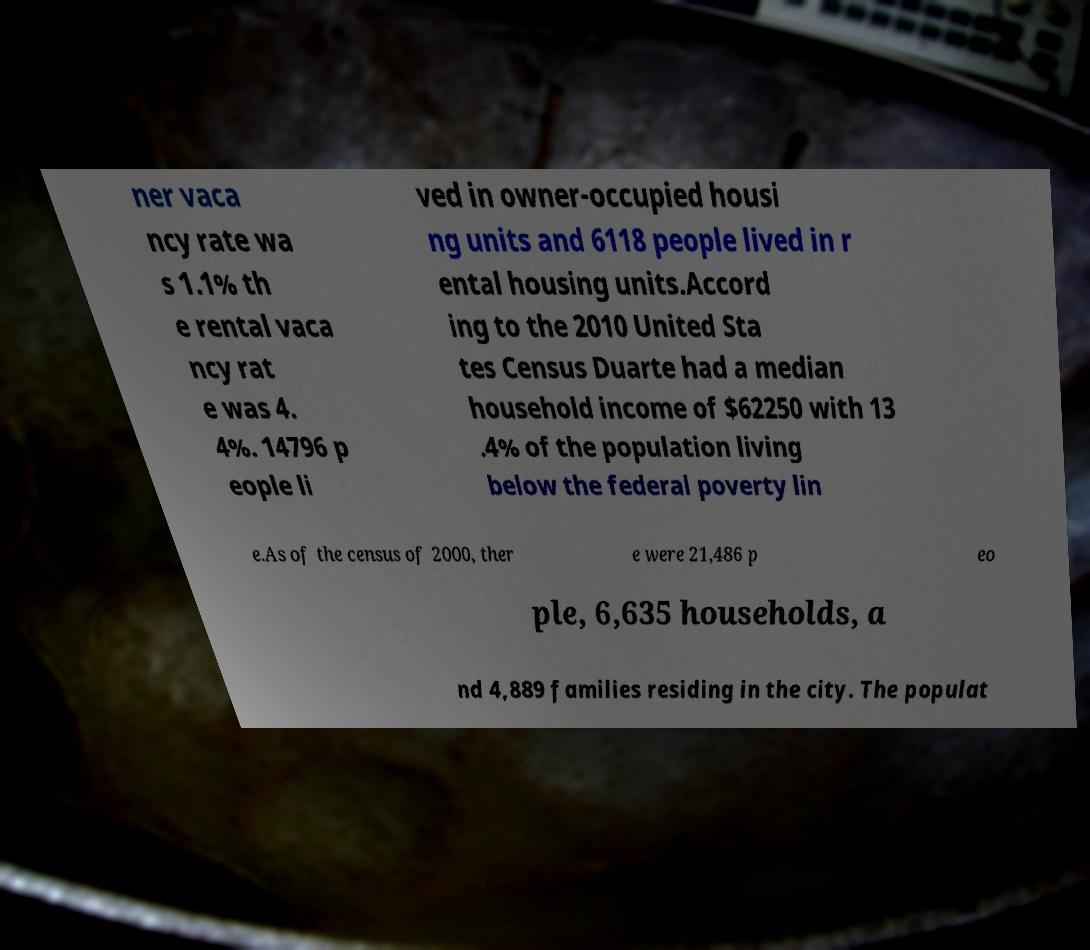Please read and relay the text visible in this image. What does it say? ner vaca ncy rate wa s 1.1% th e rental vaca ncy rat e was 4. 4%. 14796 p eople li ved in owner-occupied housi ng units and 6118 people lived in r ental housing units.Accord ing to the 2010 United Sta tes Census Duarte had a median household income of $62250 with 13 .4% of the population living below the federal poverty lin e.As of the census of 2000, ther e were 21,486 p eo ple, 6,635 households, a nd 4,889 families residing in the city. The populat 